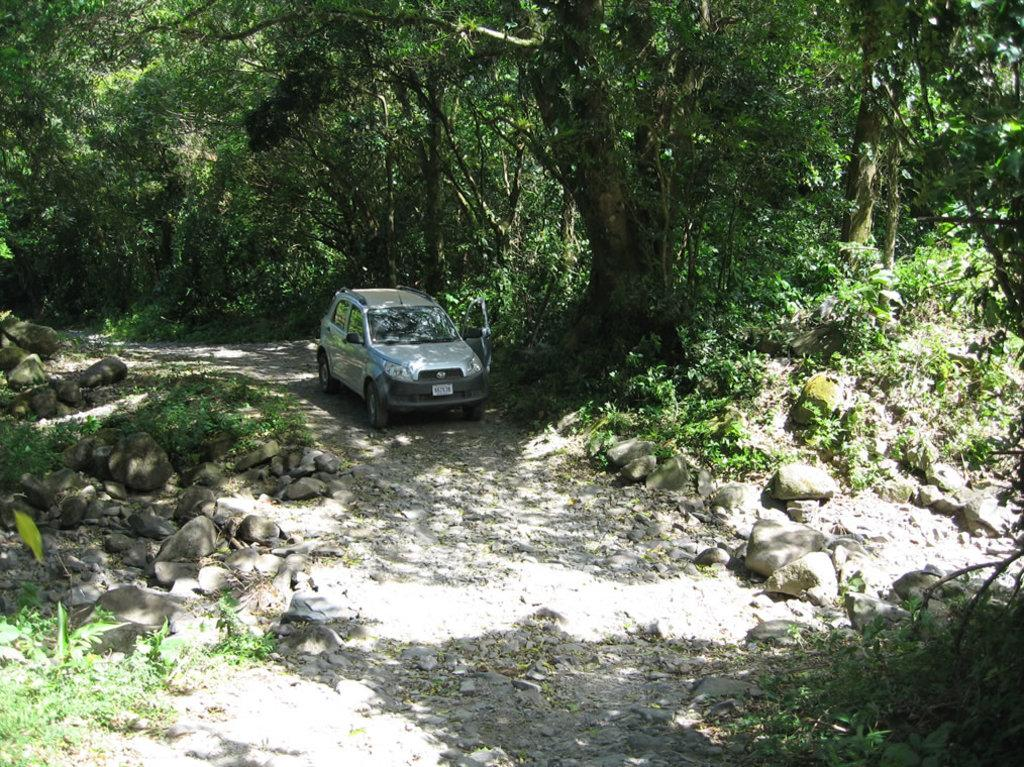What is the main object on the ground in the image? There is a car on the ground in the image. What type of natural elements can be seen in the image? There are many trees and stones in the image. What type of flowers can be seen growing on the car in the image? There are no flowers growing on the car in the image. What order are the trees arranged in the image? The trees are not arranged in any specific order in the image; they are randomly distributed. 